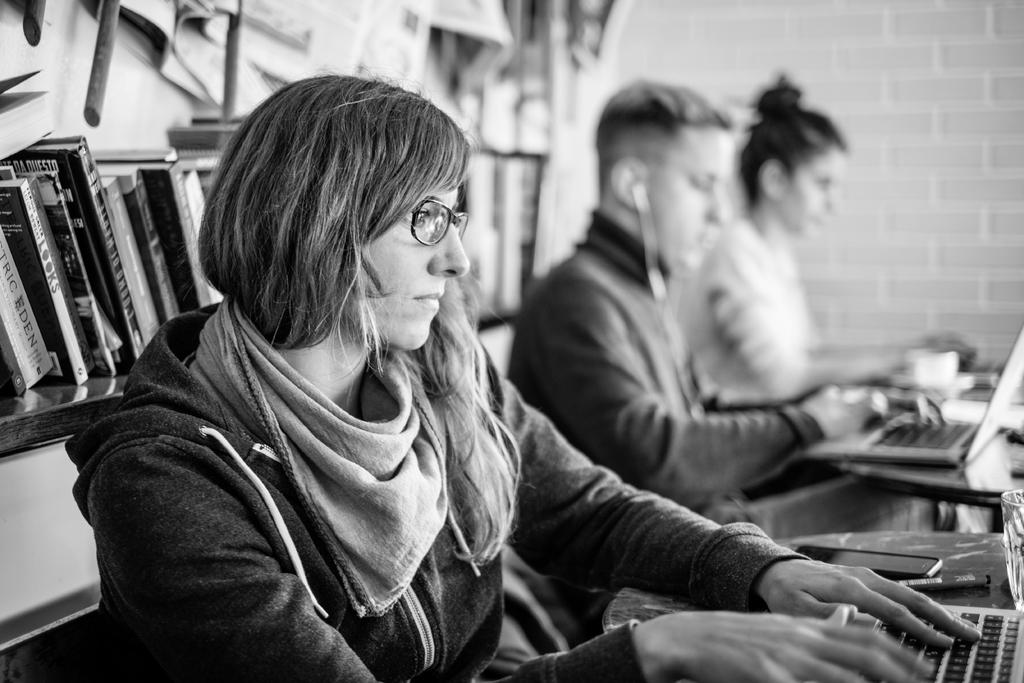Provide a one-sentence caption for the provided image. a black and white photo of a trio of people typing at their computers with books behind them with a lot of blurriness, but one book reads LOOKS. 